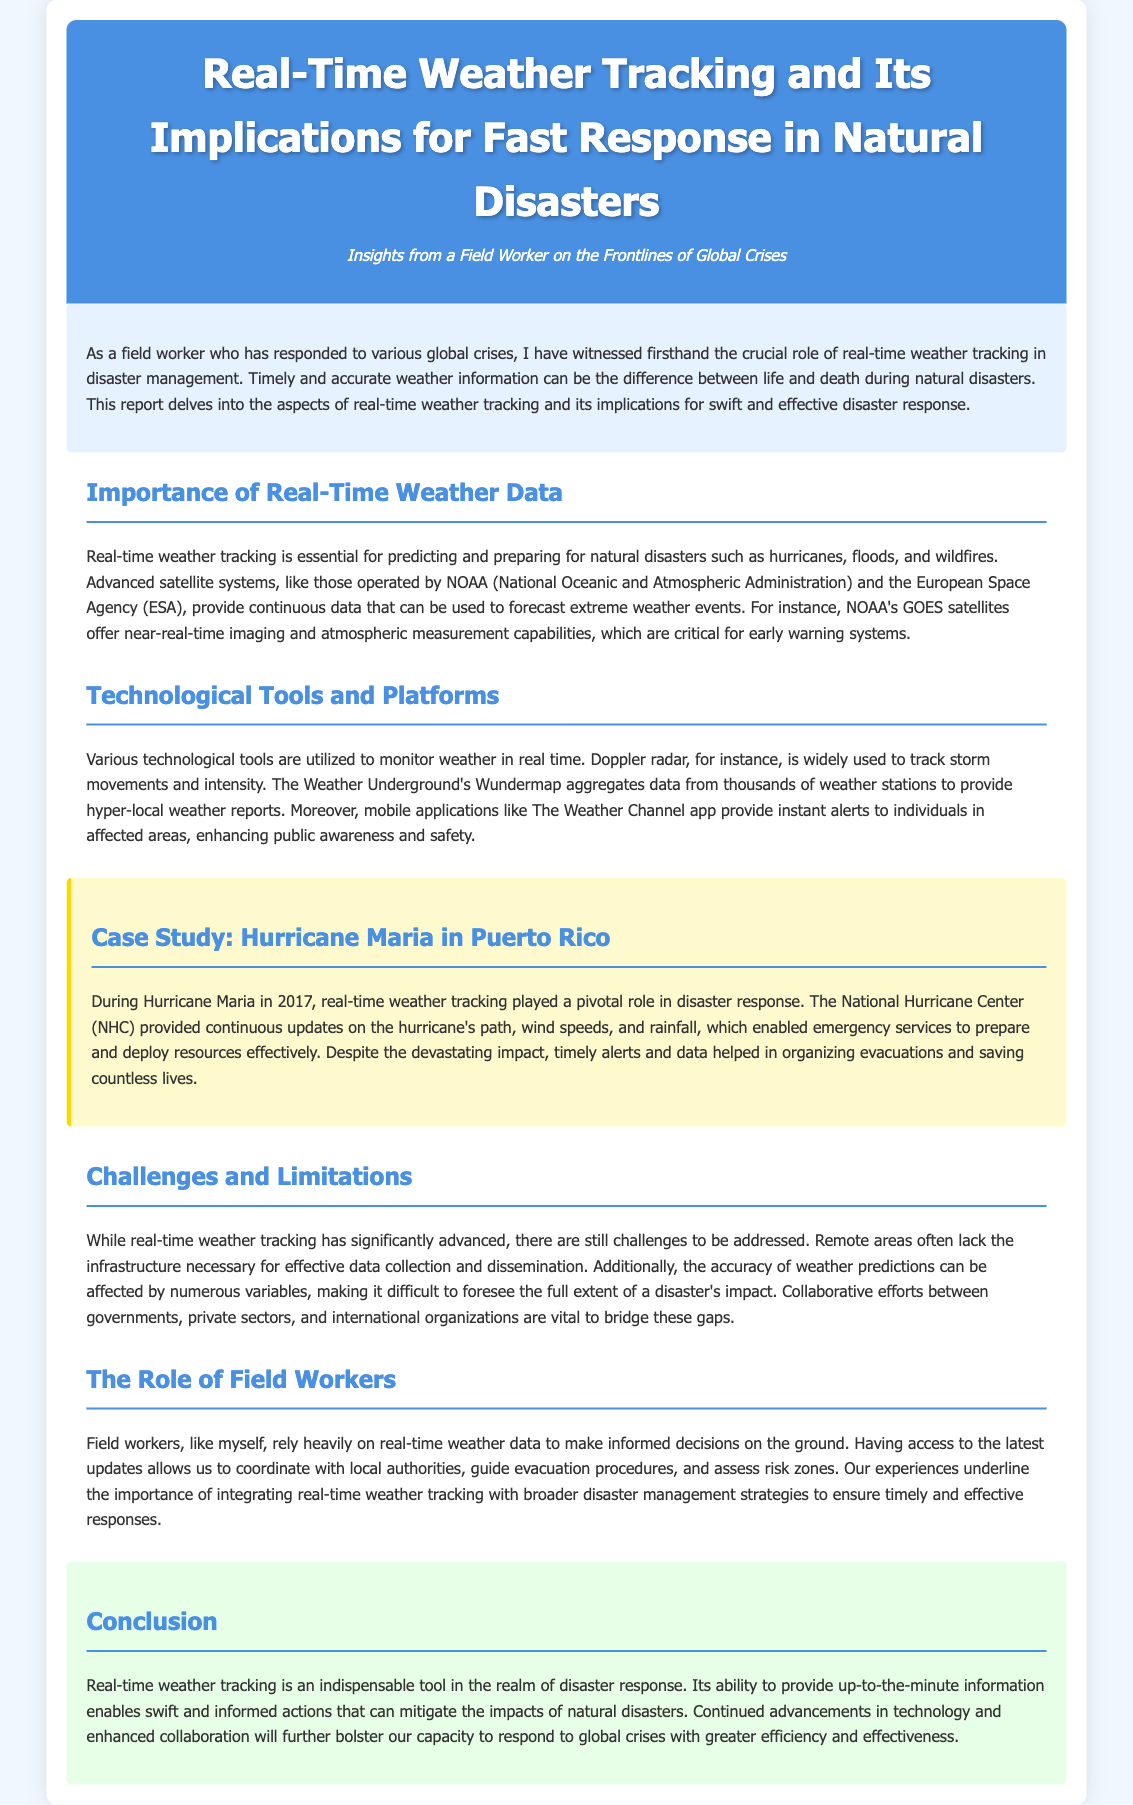what is the title of the report? The title of the report is highlighted in the header and clearly states the focus of the document.
Answer: Real-Time Weather Tracking and Its Implications for Fast Response in Natural Disasters who provided continuous updates during Hurricane Maria? The case study mentions an organization that provided crucial information during the hurricane event.
Answer: National Hurricane Center what technological tool is widely used to track storm movements? The section discussing technological tools highlights a specific technology that is essential for storm tracking.
Answer: Doppler radar in what year did Hurricane Maria occur? The case study specifies a year related to the natural disaster being discussed.
Answer: 2017 what aspect does the report emphasize about real-time weather data? The introduction outlines the critical role of weather data in disaster scenarios.
Answer: essential for predicting and preparing for natural disasters what does the report suggest is vital to address challenges in weather tracking? The challenges section discusses the need for cooperation among different sectors to enhance effective weather data use.
Answer: collaborative efforts what color is the background of the conclusion section? The document describes the appearance of the conclusion section, including its colors.
Answer: e6ffe6 what two organizations are mentioned that operate advanced satellite systems? The document lists agencies involved in weather tracking technology, highlighting significant contributors in the field.
Answer: NOAA and European Space Agency what type of platform does Weather Underground provide? This refers to a specific type of information service covered in the document.
Answer: hyper-local weather reports 